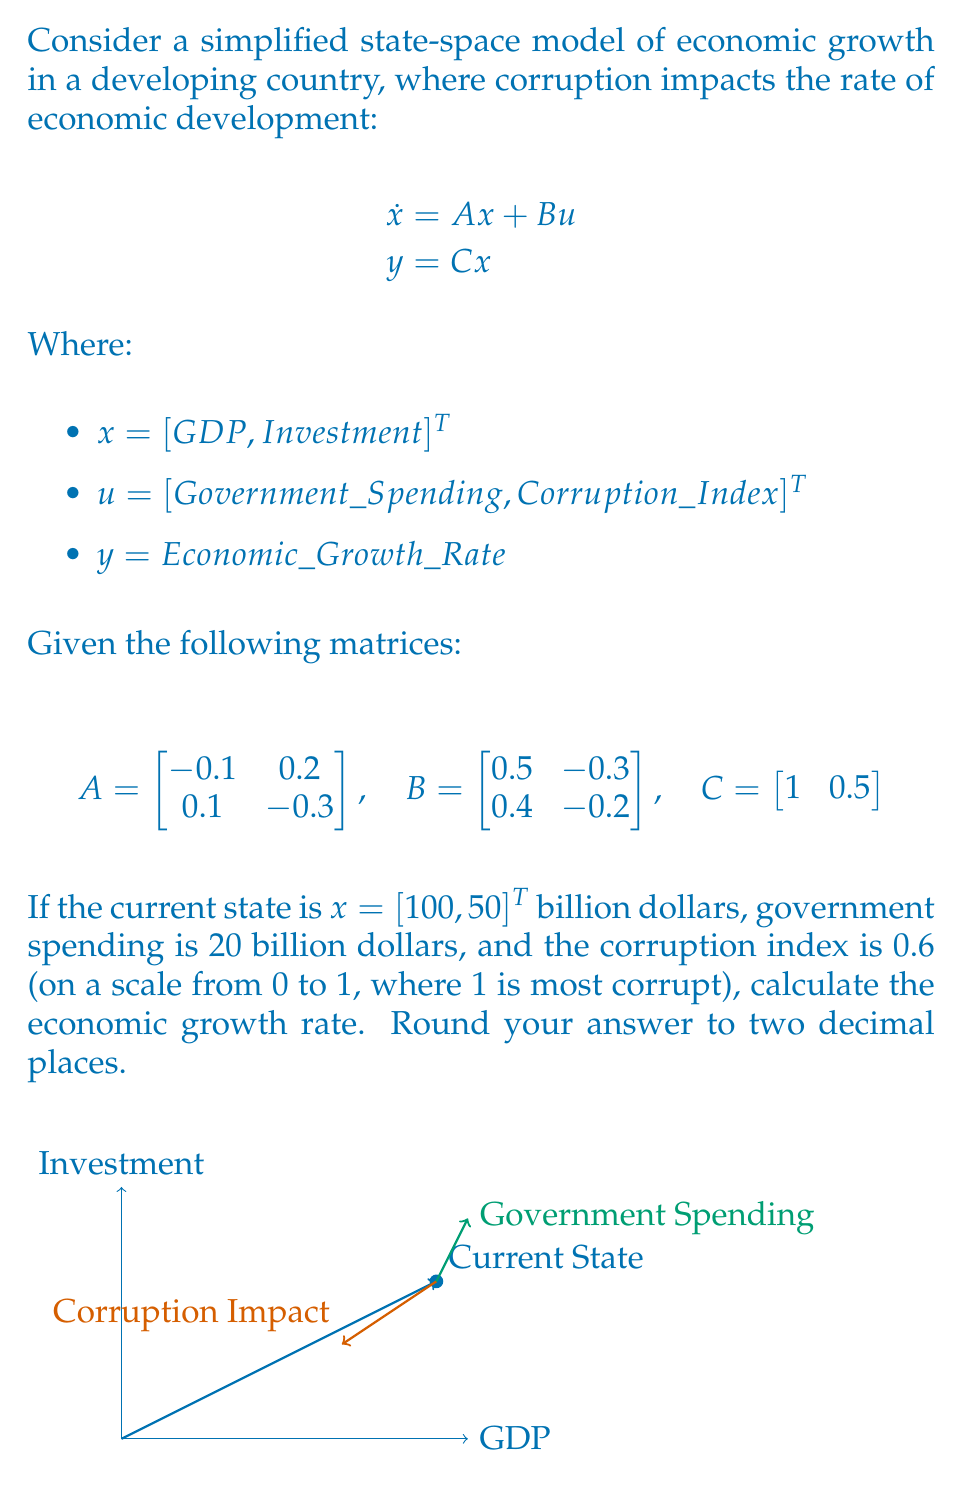Can you answer this question? To solve this problem, we'll follow these steps:

1) First, we need to calculate $\dot{x}$ using the state equation:

   $$\dot{x} = Ax + Bu$$

2) Let's calculate $Ax$:

   $$Ax = \begin{bmatrix} -0.1 & 0.2 \\ 0.1 & -0.3 \end{bmatrix} \begin{bmatrix} 100 \\ 50 \end{bmatrix} = \begin{bmatrix} -10 + 10 \\ 10 - 15 \end{bmatrix} = \begin{bmatrix} 0 \\ -5 \end{bmatrix}$$

3) Now, let's calculate $Bu$:

   $$Bu = \begin{bmatrix} 0.5 & -0.3 \\ 0.4 & -0.2 \end{bmatrix} \begin{bmatrix} 20 \\ 0.6 \end{bmatrix} = \begin{bmatrix} 10 - 0.18 \\ 8 - 0.12 \end{bmatrix} = \begin{bmatrix} 9.82 \\ 7.88 \end{bmatrix}$$

4) Now we can calculate $\dot{x}$:

   $$\dot{x} = \begin{bmatrix} 0 \\ -5 \end{bmatrix} + \begin{bmatrix} 9.82 \\ 7.88 \end{bmatrix} = \begin{bmatrix} 9.82 \\ 2.88 \end{bmatrix}$$

5) Finally, we can calculate the economic growth rate $y$ using the output equation:

   $$y = Cx = \begin{bmatrix} 1 & 0.5 \end{bmatrix} \begin{bmatrix} 9.82 \\ 2.88 \end{bmatrix} = 9.82 + 1.44 = 11.26$$

6) Rounding to two decimal places, we get 11.26.
Answer: 11.26 